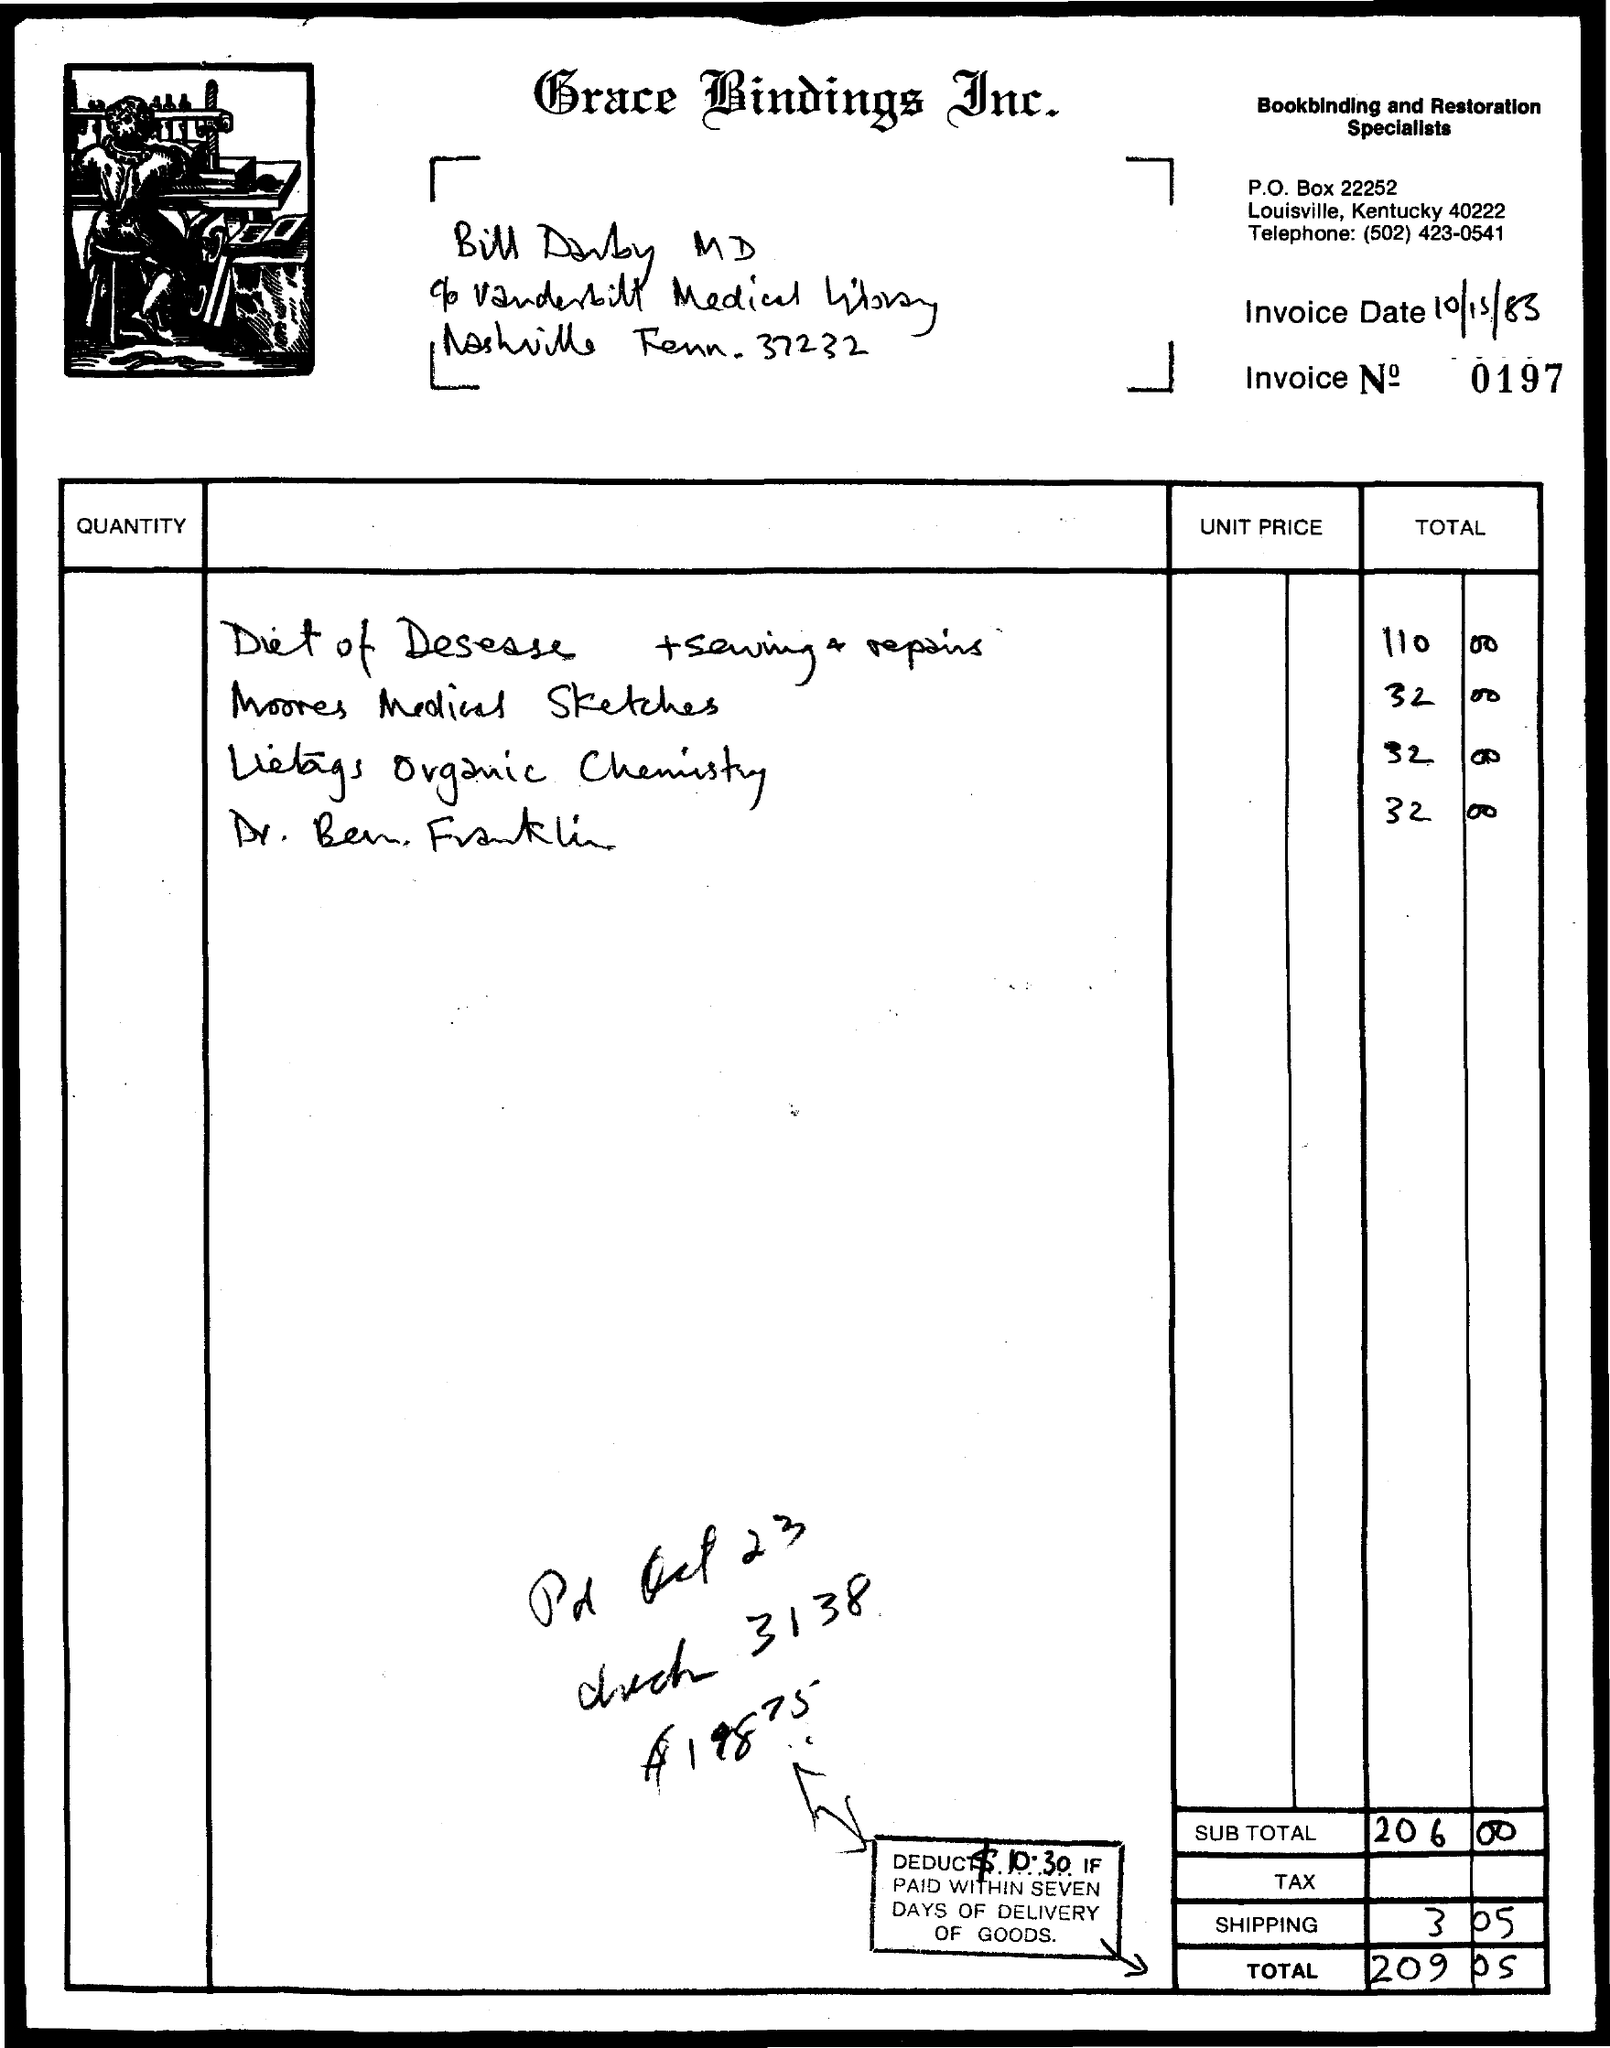What is the Invoice Date?
Make the answer very short. 10/15/83. What is the Invoice No.?
Give a very brief answer. 0197. What is the sub Total?
Your response must be concise. 206 00. What is the Total?
Offer a terse response. 209.05. 